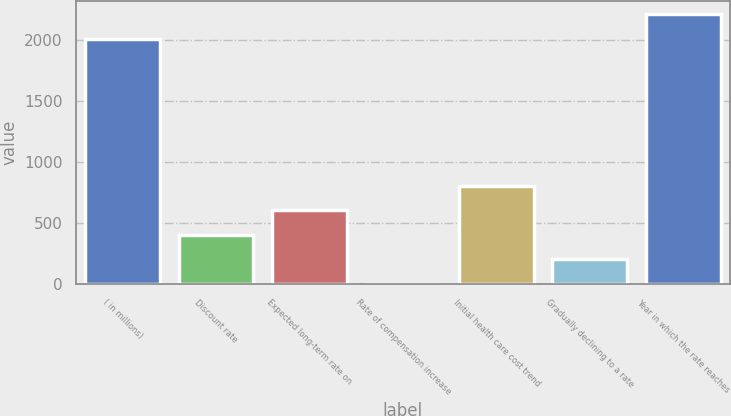Convert chart to OTSL. <chart><loc_0><loc_0><loc_500><loc_500><bar_chart><fcel>( in millions)<fcel>Discount rate<fcel>Expected long-term rate on<fcel>Rate of compensation increase<fcel>Initial health care cost trend<fcel>Gradually declining to a rate<fcel>Year in which the rate reaches<nl><fcel>2012<fcel>406.52<fcel>607.96<fcel>3.64<fcel>809.4<fcel>205.08<fcel>2213.44<nl></chart> 